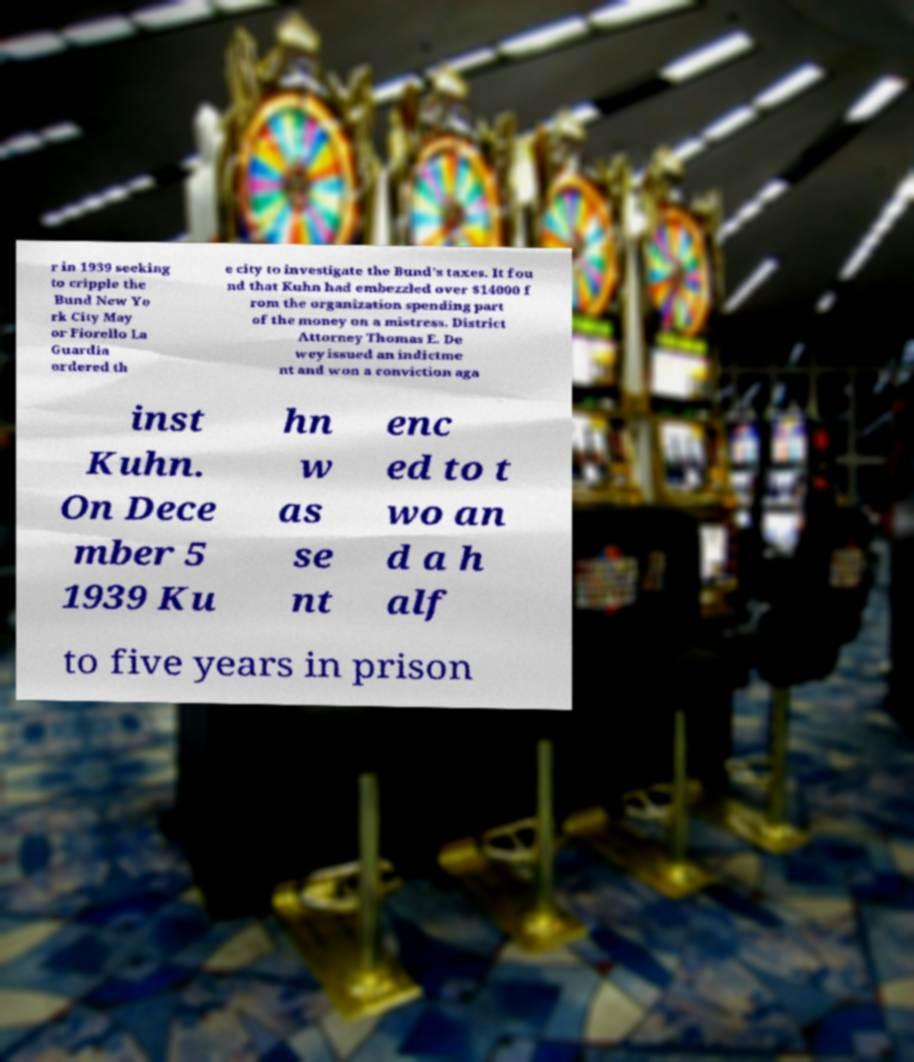Please identify and transcribe the text found in this image. r in 1939 seeking to cripple the Bund New Yo rk City May or Fiorello La Guardia ordered th e city to investigate the Bund's taxes. It fou nd that Kuhn had embezzled over $14000 f rom the organization spending part of the money on a mistress. District Attorney Thomas E. De wey issued an indictme nt and won a conviction aga inst Kuhn. On Dece mber 5 1939 Ku hn w as se nt enc ed to t wo an d a h alf to five years in prison 